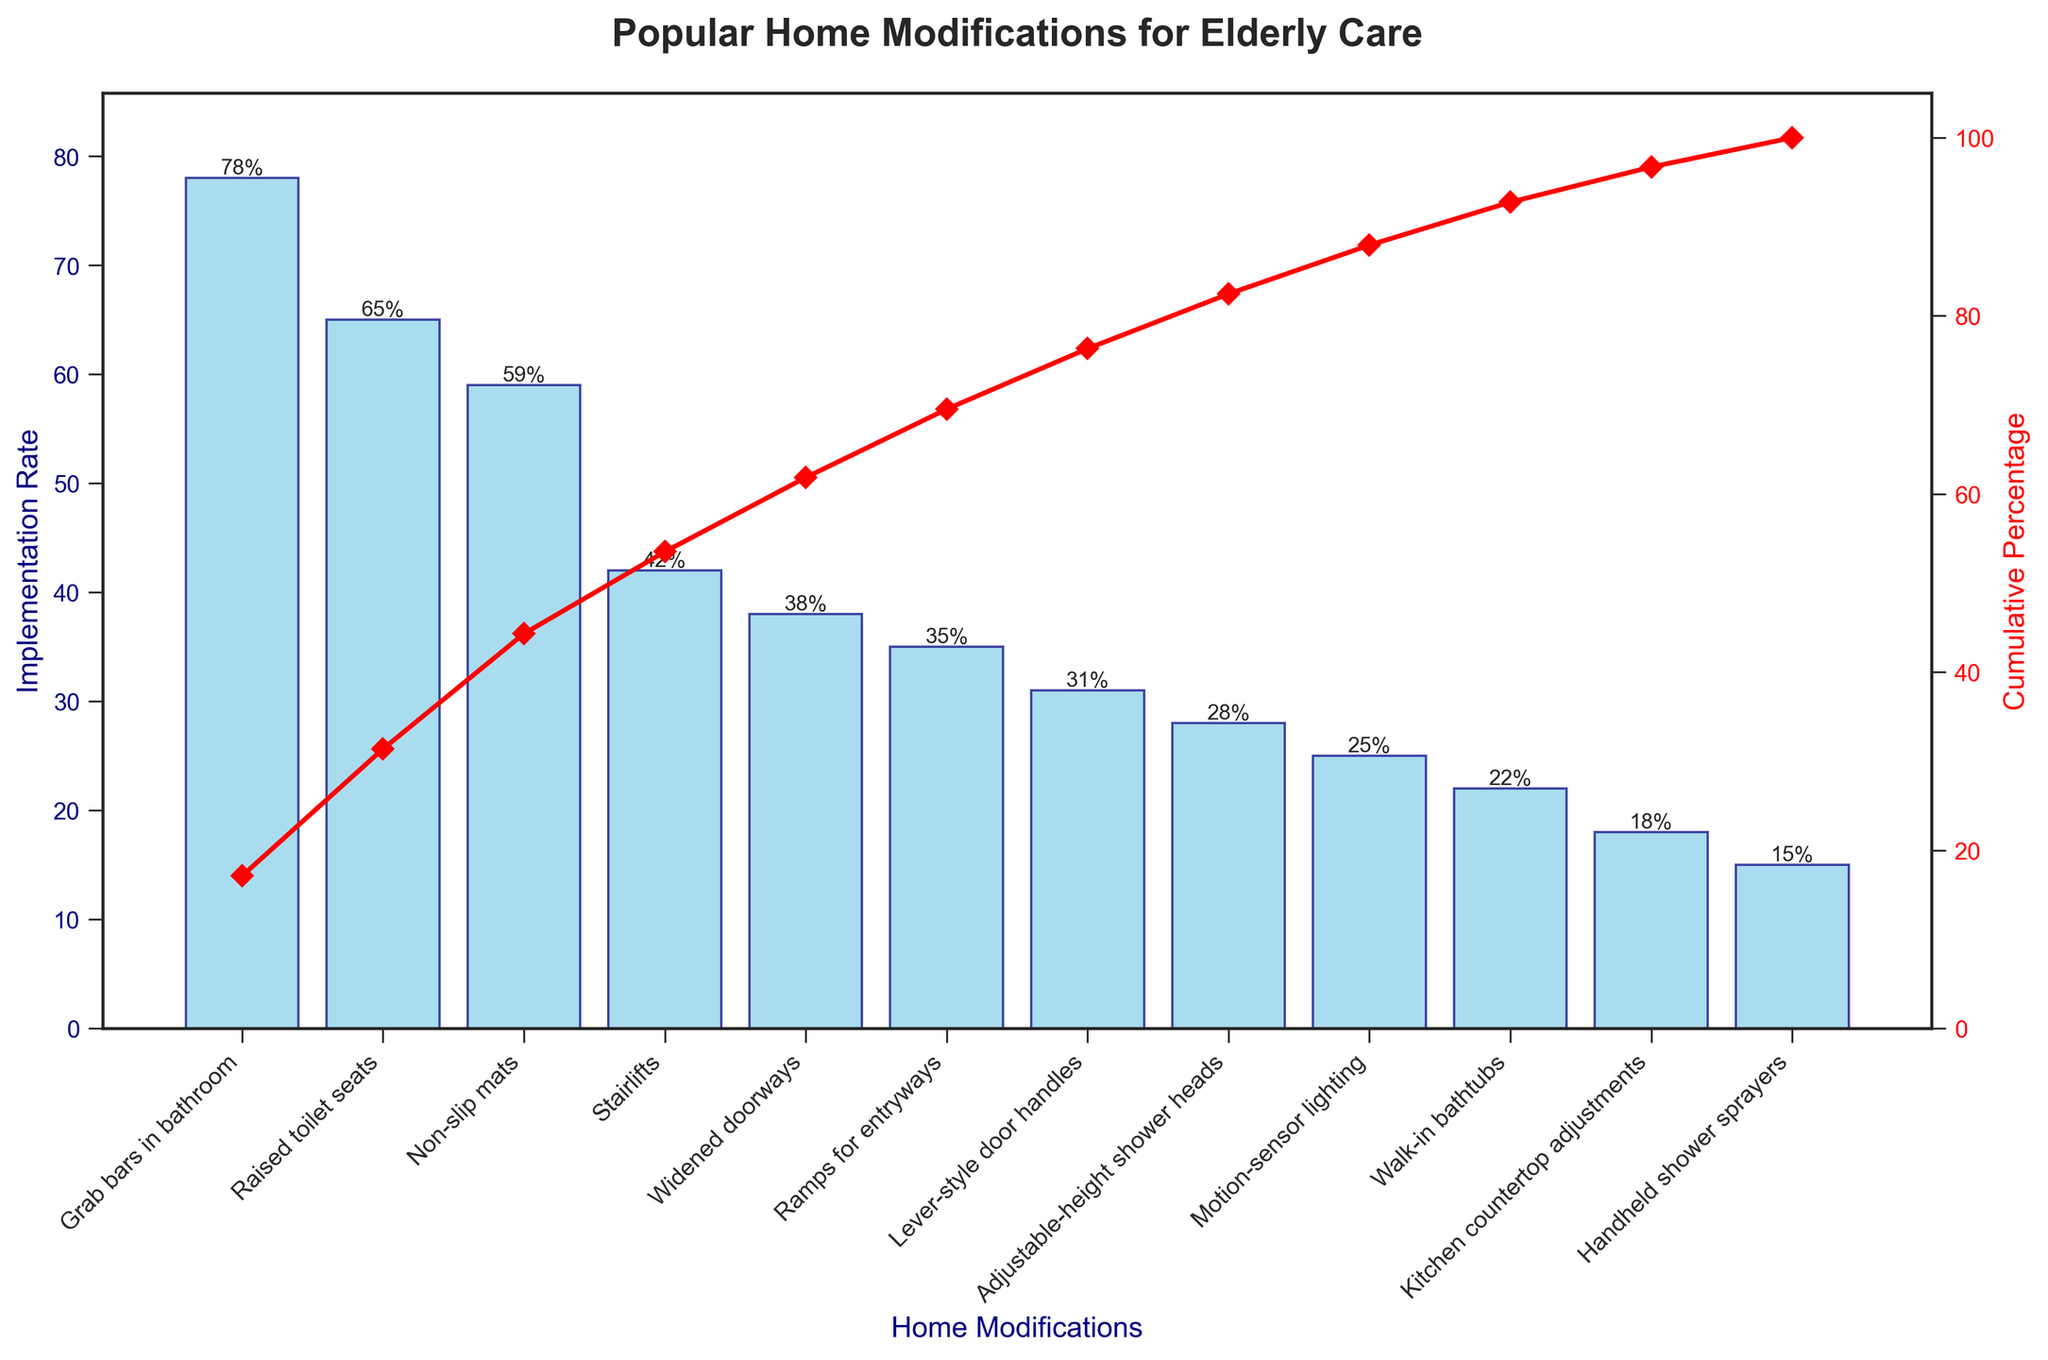What's the title of the chart? The title is written at the top of the chart and provides a summary of what the chart represents.
Answer: Popular Home Modifications for Elderly Care Which home modification has the highest implementation rate? Check the highest bar in the chart, which represents the modification with the highest implementation rate. The label below this bar will give the modification name.
Answer: Grab bars in bathroom What is the implementation rate of adjustable-height shower heads? Locate the bar for adjustable-height shower heads by finding its label on the x-axis and then read the corresponding height value of the bar.
Answer: 28% What percentage of the total implementation rate is accounted for by the top three modifications? Sum up the implementation rates of the top three modifications (78 + 65 + 59) and divide by the total implementation rate (78 + 65 + 59 + 42 + 38 + 35 + 31 + 28 + 25 + 22 + 18 + 15), then multiply by 100 to convert to percentage.
Answer: 61% How does the implementation rate of stairlifts compare to that of ramps for entryways? Identify the bars for stairlifts and ramps for entryways by their labels on the x-axis, then compare their heights.
Answer: Stairlifts have a higher implementation rate than ramps for entryways Which modification appears at the 4th position in terms of implementation rate? List the modifications in descending order of their implementation rates and find the one at the 4th position.
Answer: Stairlifts What cumulative percentage is reached by the time we include non-slip mats? Identify the cumulative percentage marked where the line intersects the bar for non-slip mats.
Answer: Approximately 67% How many modifications have an implementation rate above 30%? Count the number of bars that have heights above the 30% mark on the y-axis.
Answer: 6 Which modification has the lowest implementation rate and what is it? Find the shortest bar and read its label on the x-axis for the modification name and its height for the rate.
Answer: Handheld shower sprayers, 15% How much higher is the implementation rate of grab bars in the bathroom compared to walk-in bathtubs? Subtract the implementation rate of walk-in bathtubs from that of grab bars in the bathroom (78 - 22).
Answer: 56% 